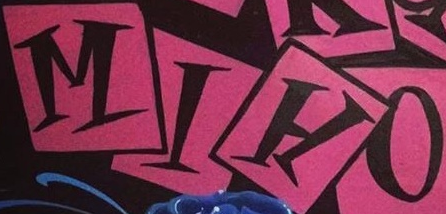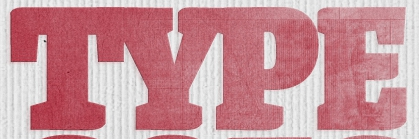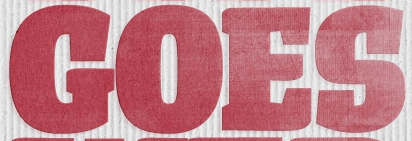Identify the words shown in these images in order, separated by a semicolon. MIHO; TYPE; GOES 